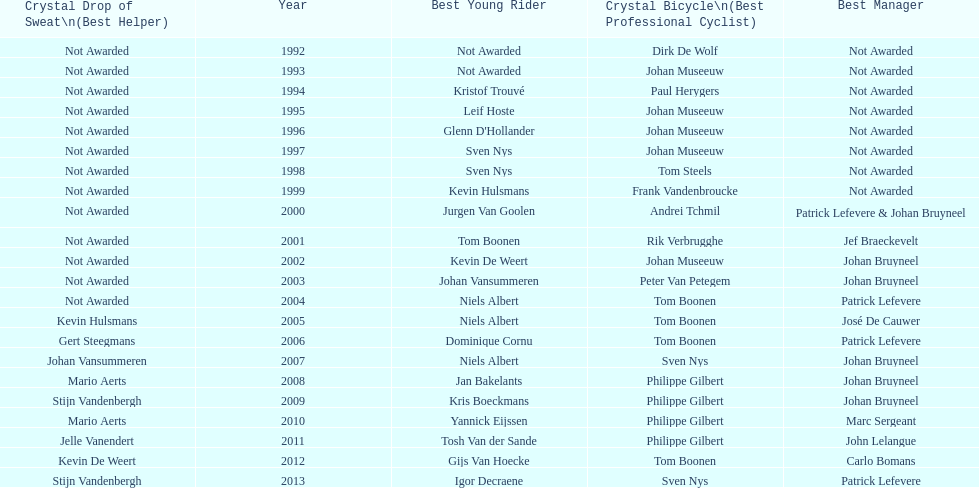Who won the crystal bicycle earlier, boonen or nys? Tom Boonen. 